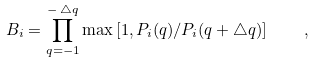<formula> <loc_0><loc_0><loc_500><loc_500>B _ { i } = \prod _ { q = - 1 } ^ { - \, \triangle q } \max \left [ 1 , P _ { i } ( q ) / P _ { i } ( q + \triangle q ) \right ] \quad ,</formula> 